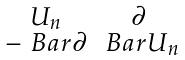Convert formula to latex. <formula><loc_0><loc_0><loc_500><loc_500>\begin{smallmatrix} U _ { n } & \partial \\ - \ B a r { \partial } & \ B a r { U } _ { n } \end{smallmatrix}</formula> 